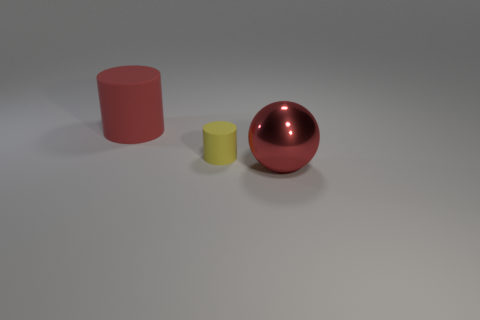Add 1 small yellow rubber things. How many objects exist? 4 Subtract all cylinders. How many objects are left? 1 Add 2 large red objects. How many large red objects exist? 4 Subtract 0 blue cylinders. How many objects are left? 3 Subtract all small yellow rubber things. Subtract all red objects. How many objects are left? 0 Add 3 red cylinders. How many red cylinders are left? 4 